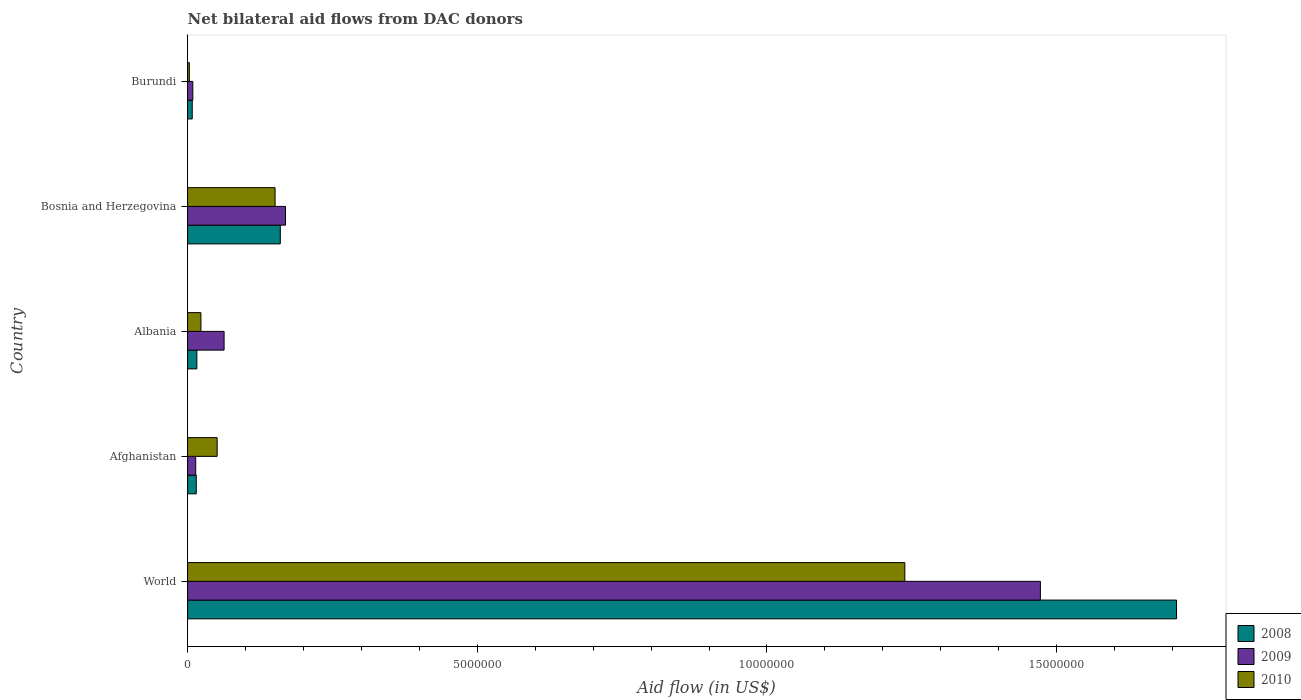How many groups of bars are there?
Offer a terse response. 5. How many bars are there on the 1st tick from the top?
Provide a succinct answer. 3. How many bars are there on the 2nd tick from the bottom?
Provide a short and direct response. 3. What is the label of the 3rd group of bars from the top?
Your response must be concise. Albania. In how many cases, is the number of bars for a given country not equal to the number of legend labels?
Your response must be concise. 0. Across all countries, what is the maximum net bilateral aid flow in 2009?
Offer a terse response. 1.47e+07. In which country was the net bilateral aid flow in 2010 minimum?
Keep it short and to the point. Burundi. What is the total net bilateral aid flow in 2008 in the graph?
Your answer should be very brief. 1.91e+07. What is the difference between the net bilateral aid flow in 2008 in Burundi and the net bilateral aid flow in 2009 in Bosnia and Herzegovina?
Your answer should be compact. -1.61e+06. What is the average net bilateral aid flow in 2009 per country?
Provide a succinct answer. 3.45e+06. What is the difference between the net bilateral aid flow in 2010 and net bilateral aid flow in 2009 in Afghanistan?
Ensure brevity in your answer.  3.70e+05. In how many countries, is the net bilateral aid flow in 2008 greater than 3000000 US$?
Make the answer very short. 1. What is the ratio of the net bilateral aid flow in 2009 in Bosnia and Herzegovina to that in Burundi?
Give a very brief answer. 18.78. Is the net bilateral aid flow in 2010 in Afghanistan less than that in Albania?
Offer a terse response. No. Is the difference between the net bilateral aid flow in 2010 in Afghanistan and Bosnia and Herzegovina greater than the difference between the net bilateral aid flow in 2009 in Afghanistan and Bosnia and Herzegovina?
Ensure brevity in your answer.  Yes. What is the difference between the highest and the second highest net bilateral aid flow in 2010?
Your response must be concise. 1.09e+07. What is the difference between the highest and the lowest net bilateral aid flow in 2009?
Provide a succinct answer. 1.46e+07. In how many countries, is the net bilateral aid flow in 2009 greater than the average net bilateral aid flow in 2009 taken over all countries?
Make the answer very short. 1. What does the 1st bar from the top in Bosnia and Herzegovina represents?
Keep it short and to the point. 2010. What does the 3rd bar from the bottom in Burundi represents?
Offer a very short reply. 2010. How many bars are there?
Keep it short and to the point. 15. Are all the bars in the graph horizontal?
Offer a very short reply. Yes. How many countries are there in the graph?
Provide a succinct answer. 5. Are the values on the major ticks of X-axis written in scientific E-notation?
Provide a short and direct response. No. Where does the legend appear in the graph?
Your answer should be very brief. Bottom right. How many legend labels are there?
Provide a succinct answer. 3. How are the legend labels stacked?
Give a very brief answer. Vertical. What is the title of the graph?
Offer a very short reply. Net bilateral aid flows from DAC donors. Does "1966" appear as one of the legend labels in the graph?
Provide a succinct answer. No. What is the label or title of the X-axis?
Your answer should be compact. Aid flow (in US$). What is the label or title of the Y-axis?
Keep it short and to the point. Country. What is the Aid flow (in US$) in 2008 in World?
Ensure brevity in your answer.  1.71e+07. What is the Aid flow (in US$) of 2009 in World?
Your answer should be very brief. 1.47e+07. What is the Aid flow (in US$) of 2010 in World?
Offer a very short reply. 1.24e+07. What is the Aid flow (in US$) in 2009 in Afghanistan?
Provide a short and direct response. 1.40e+05. What is the Aid flow (in US$) in 2010 in Afghanistan?
Your answer should be compact. 5.10e+05. What is the Aid flow (in US$) in 2008 in Albania?
Provide a short and direct response. 1.60e+05. What is the Aid flow (in US$) in 2009 in Albania?
Your answer should be very brief. 6.30e+05. What is the Aid flow (in US$) in 2010 in Albania?
Your answer should be very brief. 2.30e+05. What is the Aid flow (in US$) of 2008 in Bosnia and Herzegovina?
Give a very brief answer. 1.60e+06. What is the Aid flow (in US$) in 2009 in Bosnia and Herzegovina?
Your answer should be very brief. 1.69e+06. What is the Aid flow (in US$) in 2010 in Bosnia and Herzegovina?
Offer a very short reply. 1.51e+06. Across all countries, what is the maximum Aid flow (in US$) in 2008?
Provide a short and direct response. 1.71e+07. Across all countries, what is the maximum Aid flow (in US$) in 2009?
Make the answer very short. 1.47e+07. Across all countries, what is the maximum Aid flow (in US$) in 2010?
Your answer should be very brief. 1.24e+07. Across all countries, what is the minimum Aid flow (in US$) of 2008?
Offer a very short reply. 8.00e+04. Across all countries, what is the minimum Aid flow (in US$) of 2009?
Keep it short and to the point. 9.00e+04. Across all countries, what is the minimum Aid flow (in US$) in 2010?
Make the answer very short. 3.00e+04. What is the total Aid flow (in US$) of 2008 in the graph?
Offer a very short reply. 1.91e+07. What is the total Aid flow (in US$) of 2009 in the graph?
Ensure brevity in your answer.  1.73e+07. What is the total Aid flow (in US$) of 2010 in the graph?
Give a very brief answer. 1.47e+07. What is the difference between the Aid flow (in US$) in 2008 in World and that in Afghanistan?
Provide a short and direct response. 1.69e+07. What is the difference between the Aid flow (in US$) in 2009 in World and that in Afghanistan?
Provide a succinct answer. 1.46e+07. What is the difference between the Aid flow (in US$) in 2010 in World and that in Afghanistan?
Your answer should be very brief. 1.19e+07. What is the difference between the Aid flow (in US$) in 2008 in World and that in Albania?
Offer a terse response. 1.69e+07. What is the difference between the Aid flow (in US$) in 2009 in World and that in Albania?
Provide a short and direct response. 1.41e+07. What is the difference between the Aid flow (in US$) of 2010 in World and that in Albania?
Keep it short and to the point. 1.22e+07. What is the difference between the Aid flow (in US$) in 2008 in World and that in Bosnia and Herzegovina?
Offer a very short reply. 1.55e+07. What is the difference between the Aid flow (in US$) in 2009 in World and that in Bosnia and Herzegovina?
Your response must be concise. 1.30e+07. What is the difference between the Aid flow (in US$) of 2010 in World and that in Bosnia and Herzegovina?
Offer a very short reply. 1.09e+07. What is the difference between the Aid flow (in US$) in 2008 in World and that in Burundi?
Your answer should be compact. 1.70e+07. What is the difference between the Aid flow (in US$) of 2009 in World and that in Burundi?
Keep it short and to the point. 1.46e+07. What is the difference between the Aid flow (in US$) in 2010 in World and that in Burundi?
Give a very brief answer. 1.24e+07. What is the difference between the Aid flow (in US$) of 2009 in Afghanistan and that in Albania?
Ensure brevity in your answer.  -4.90e+05. What is the difference between the Aid flow (in US$) in 2010 in Afghanistan and that in Albania?
Offer a very short reply. 2.80e+05. What is the difference between the Aid flow (in US$) of 2008 in Afghanistan and that in Bosnia and Herzegovina?
Your response must be concise. -1.45e+06. What is the difference between the Aid flow (in US$) of 2009 in Afghanistan and that in Bosnia and Herzegovina?
Offer a terse response. -1.55e+06. What is the difference between the Aid flow (in US$) of 2010 in Afghanistan and that in Bosnia and Herzegovina?
Offer a terse response. -1.00e+06. What is the difference between the Aid flow (in US$) in 2008 in Afghanistan and that in Burundi?
Provide a short and direct response. 7.00e+04. What is the difference between the Aid flow (in US$) of 2009 in Afghanistan and that in Burundi?
Keep it short and to the point. 5.00e+04. What is the difference between the Aid flow (in US$) in 2010 in Afghanistan and that in Burundi?
Your answer should be very brief. 4.80e+05. What is the difference between the Aid flow (in US$) of 2008 in Albania and that in Bosnia and Herzegovina?
Ensure brevity in your answer.  -1.44e+06. What is the difference between the Aid flow (in US$) in 2009 in Albania and that in Bosnia and Herzegovina?
Make the answer very short. -1.06e+06. What is the difference between the Aid flow (in US$) in 2010 in Albania and that in Bosnia and Herzegovina?
Provide a short and direct response. -1.28e+06. What is the difference between the Aid flow (in US$) of 2008 in Albania and that in Burundi?
Offer a terse response. 8.00e+04. What is the difference between the Aid flow (in US$) in 2009 in Albania and that in Burundi?
Give a very brief answer. 5.40e+05. What is the difference between the Aid flow (in US$) of 2010 in Albania and that in Burundi?
Offer a terse response. 2.00e+05. What is the difference between the Aid flow (in US$) of 2008 in Bosnia and Herzegovina and that in Burundi?
Provide a short and direct response. 1.52e+06. What is the difference between the Aid flow (in US$) in 2009 in Bosnia and Herzegovina and that in Burundi?
Your answer should be very brief. 1.60e+06. What is the difference between the Aid flow (in US$) in 2010 in Bosnia and Herzegovina and that in Burundi?
Keep it short and to the point. 1.48e+06. What is the difference between the Aid flow (in US$) of 2008 in World and the Aid flow (in US$) of 2009 in Afghanistan?
Make the answer very short. 1.69e+07. What is the difference between the Aid flow (in US$) in 2008 in World and the Aid flow (in US$) in 2010 in Afghanistan?
Provide a short and direct response. 1.66e+07. What is the difference between the Aid flow (in US$) of 2009 in World and the Aid flow (in US$) of 2010 in Afghanistan?
Provide a short and direct response. 1.42e+07. What is the difference between the Aid flow (in US$) of 2008 in World and the Aid flow (in US$) of 2009 in Albania?
Provide a succinct answer. 1.64e+07. What is the difference between the Aid flow (in US$) in 2008 in World and the Aid flow (in US$) in 2010 in Albania?
Your answer should be very brief. 1.68e+07. What is the difference between the Aid flow (in US$) of 2009 in World and the Aid flow (in US$) of 2010 in Albania?
Provide a succinct answer. 1.45e+07. What is the difference between the Aid flow (in US$) in 2008 in World and the Aid flow (in US$) in 2009 in Bosnia and Herzegovina?
Your answer should be compact. 1.54e+07. What is the difference between the Aid flow (in US$) in 2008 in World and the Aid flow (in US$) in 2010 in Bosnia and Herzegovina?
Your response must be concise. 1.56e+07. What is the difference between the Aid flow (in US$) of 2009 in World and the Aid flow (in US$) of 2010 in Bosnia and Herzegovina?
Your response must be concise. 1.32e+07. What is the difference between the Aid flow (in US$) in 2008 in World and the Aid flow (in US$) in 2009 in Burundi?
Your answer should be compact. 1.70e+07. What is the difference between the Aid flow (in US$) in 2008 in World and the Aid flow (in US$) in 2010 in Burundi?
Your answer should be compact. 1.70e+07. What is the difference between the Aid flow (in US$) in 2009 in World and the Aid flow (in US$) in 2010 in Burundi?
Provide a succinct answer. 1.47e+07. What is the difference between the Aid flow (in US$) of 2008 in Afghanistan and the Aid flow (in US$) of 2009 in Albania?
Provide a succinct answer. -4.80e+05. What is the difference between the Aid flow (in US$) in 2008 in Afghanistan and the Aid flow (in US$) in 2010 in Albania?
Provide a short and direct response. -8.00e+04. What is the difference between the Aid flow (in US$) of 2008 in Afghanistan and the Aid flow (in US$) of 2009 in Bosnia and Herzegovina?
Keep it short and to the point. -1.54e+06. What is the difference between the Aid flow (in US$) of 2008 in Afghanistan and the Aid flow (in US$) of 2010 in Bosnia and Herzegovina?
Keep it short and to the point. -1.36e+06. What is the difference between the Aid flow (in US$) in 2009 in Afghanistan and the Aid flow (in US$) in 2010 in Bosnia and Herzegovina?
Your response must be concise. -1.37e+06. What is the difference between the Aid flow (in US$) of 2008 in Afghanistan and the Aid flow (in US$) of 2009 in Burundi?
Make the answer very short. 6.00e+04. What is the difference between the Aid flow (in US$) in 2009 in Afghanistan and the Aid flow (in US$) in 2010 in Burundi?
Ensure brevity in your answer.  1.10e+05. What is the difference between the Aid flow (in US$) in 2008 in Albania and the Aid flow (in US$) in 2009 in Bosnia and Herzegovina?
Provide a succinct answer. -1.53e+06. What is the difference between the Aid flow (in US$) of 2008 in Albania and the Aid flow (in US$) of 2010 in Bosnia and Herzegovina?
Your answer should be compact. -1.35e+06. What is the difference between the Aid flow (in US$) in 2009 in Albania and the Aid flow (in US$) in 2010 in Bosnia and Herzegovina?
Provide a succinct answer. -8.80e+05. What is the difference between the Aid flow (in US$) of 2008 in Albania and the Aid flow (in US$) of 2010 in Burundi?
Your answer should be compact. 1.30e+05. What is the difference between the Aid flow (in US$) in 2008 in Bosnia and Herzegovina and the Aid flow (in US$) in 2009 in Burundi?
Your answer should be compact. 1.51e+06. What is the difference between the Aid flow (in US$) in 2008 in Bosnia and Herzegovina and the Aid flow (in US$) in 2010 in Burundi?
Offer a very short reply. 1.57e+06. What is the difference between the Aid flow (in US$) of 2009 in Bosnia and Herzegovina and the Aid flow (in US$) of 2010 in Burundi?
Offer a terse response. 1.66e+06. What is the average Aid flow (in US$) in 2008 per country?
Provide a succinct answer. 3.81e+06. What is the average Aid flow (in US$) in 2009 per country?
Ensure brevity in your answer.  3.45e+06. What is the average Aid flow (in US$) of 2010 per country?
Your response must be concise. 2.93e+06. What is the difference between the Aid flow (in US$) in 2008 and Aid flow (in US$) in 2009 in World?
Keep it short and to the point. 2.35e+06. What is the difference between the Aid flow (in US$) of 2008 and Aid flow (in US$) of 2010 in World?
Give a very brief answer. 4.69e+06. What is the difference between the Aid flow (in US$) in 2009 and Aid flow (in US$) in 2010 in World?
Your response must be concise. 2.34e+06. What is the difference between the Aid flow (in US$) in 2008 and Aid flow (in US$) in 2009 in Afghanistan?
Your answer should be compact. 10000. What is the difference between the Aid flow (in US$) of 2008 and Aid flow (in US$) of 2010 in Afghanistan?
Your answer should be very brief. -3.60e+05. What is the difference between the Aid flow (in US$) in 2009 and Aid flow (in US$) in 2010 in Afghanistan?
Give a very brief answer. -3.70e+05. What is the difference between the Aid flow (in US$) of 2008 and Aid flow (in US$) of 2009 in Albania?
Offer a terse response. -4.70e+05. What is the difference between the Aid flow (in US$) of 2008 and Aid flow (in US$) of 2010 in Bosnia and Herzegovina?
Your answer should be compact. 9.00e+04. What is the difference between the Aid flow (in US$) in 2009 and Aid flow (in US$) in 2010 in Bosnia and Herzegovina?
Offer a very short reply. 1.80e+05. What is the difference between the Aid flow (in US$) in 2008 and Aid flow (in US$) in 2009 in Burundi?
Give a very brief answer. -10000. What is the difference between the Aid flow (in US$) of 2008 and Aid flow (in US$) of 2010 in Burundi?
Your answer should be compact. 5.00e+04. What is the ratio of the Aid flow (in US$) in 2008 in World to that in Afghanistan?
Offer a very short reply. 113.8. What is the ratio of the Aid flow (in US$) of 2009 in World to that in Afghanistan?
Keep it short and to the point. 105.14. What is the ratio of the Aid flow (in US$) of 2010 in World to that in Afghanistan?
Offer a terse response. 24.27. What is the ratio of the Aid flow (in US$) of 2008 in World to that in Albania?
Provide a succinct answer. 106.69. What is the ratio of the Aid flow (in US$) in 2009 in World to that in Albania?
Your answer should be compact. 23.37. What is the ratio of the Aid flow (in US$) in 2010 in World to that in Albania?
Make the answer very short. 53.83. What is the ratio of the Aid flow (in US$) in 2008 in World to that in Bosnia and Herzegovina?
Give a very brief answer. 10.67. What is the ratio of the Aid flow (in US$) of 2009 in World to that in Bosnia and Herzegovina?
Offer a terse response. 8.71. What is the ratio of the Aid flow (in US$) in 2010 in World to that in Bosnia and Herzegovina?
Offer a very short reply. 8.2. What is the ratio of the Aid flow (in US$) in 2008 in World to that in Burundi?
Ensure brevity in your answer.  213.38. What is the ratio of the Aid flow (in US$) of 2009 in World to that in Burundi?
Make the answer very short. 163.56. What is the ratio of the Aid flow (in US$) in 2010 in World to that in Burundi?
Make the answer very short. 412.67. What is the ratio of the Aid flow (in US$) in 2008 in Afghanistan to that in Albania?
Your answer should be compact. 0.94. What is the ratio of the Aid flow (in US$) of 2009 in Afghanistan to that in Albania?
Your answer should be very brief. 0.22. What is the ratio of the Aid flow (in US$) in 2010 in Afghanistan to that in Albania?
Give a very brief answer. 2.22. What is the ratio of the Aid flow (in US$) of 2008 in Afghanistan to that in Bosnia and Herzegovina?
Provide a short and direct response. 0.09. What is the ratio of the Aid flow (in US$) in 2009 in Afghanistan to that in Bosnia and Herzegovina?
Provide a succinct answer. 0.08. What is the ratio of the Aid flow (in US$) of 2010 in Afghanistan to that in Bosnia and Herzegovina?
Provide a short and direct response. 0.34. What is the ratio of the Aid flow (in US$) in 2008 in Afghanistan to that in Burundi?
Your answer should be very brief. 1.88. What is the ratio of the Aid flow (in US$) in 2009 in Afghanistan to that in Burundi?
Provide a short and direct response. 1.56. What is the ratio of the Aid flow (in US$) of 2009 in Albania to that in Bosnia and Herzegovina?
Your answer should be very brief. 0.37. What is the ratio of the Aid flow (in US$) of 2010 in Albania to that in Bosnia and Herzegovina?
Provide a succinct answer. 0.15. What is the ratio of the Aid flow (in US$) of 2008 in Albania to that in Burundi?
Ensure brevity in your answer.  2. What is the ratio of the Aid flow (in US$) in 2009 in Albania to that in Burundi?
Your response must be concise. 7. What is the ratio of the Aid flow (in US$) of 2010 in Albania to that in Burundi?
Your answer should be very brief. 7.67. What is the ratio of the Aid flow (in US$) of 2008 in Bosnia and Herzegovina to that in Burundi?
Offer a very short reply. 20. What is the ratio of the Aid flow (in US$) of 2009 in Bosnia and Herzegovina to that in Burundi?
Offer a very short reply. 18.78. What is the ratio of the Aid flow (in US$) of 2010 in Bosnia and Herzegovina to that in Burundi?
Make the answer very short. 50.33. What is the difference between the highest and the second highest Aid flow (in US$) of 2008?
Your answer should be very brief. 1.55e+07. What is the difference between the highest and the second highest Aid flow (in US$) of 2009?
Your answer should be very brief. 1.30e+07. What is the difference between the highest and the second highest Aid flow (in US$) of 2010?
Offer a terse response. 1.09e+07. What is the difference between the highest and the lowest Aid flow (in US$) of 2008?
Your answer should be compact. 1.70e+07. What is the difference between the highest and the lowest Aid flow (in US$) in 2009?
Ensure brevity in your answer.  1.46e+07. What is the difference between the highest and the lowest Aid flow (in US$) in 2010?
Offer a very short reply. 1.24e+07. 